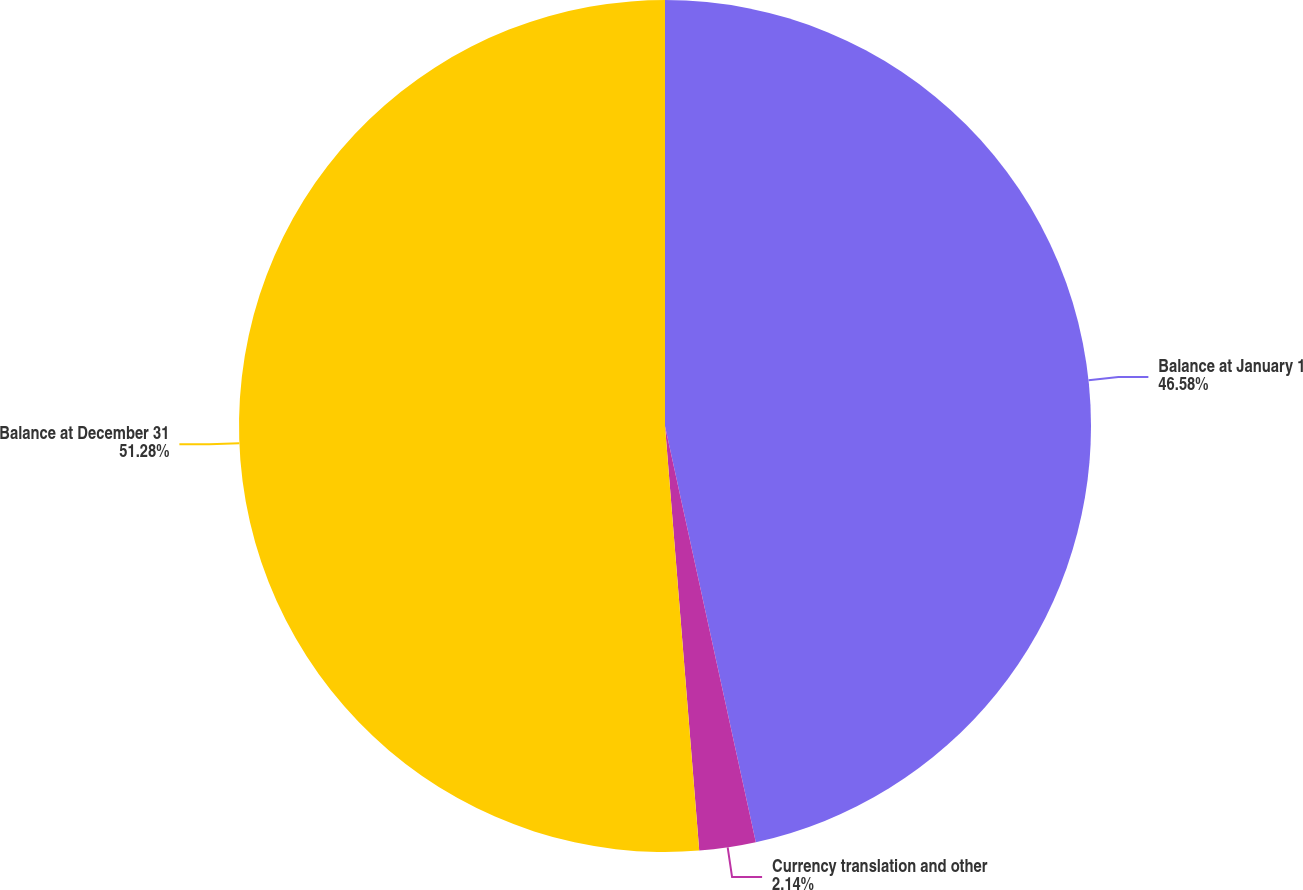Convert chart to OTSL. <chart><loc_0><loc_0><loc_500><loc_500><pie_chart><fcel>Balance at January 1<fcel>Currency translation and other<fcel>Balance at December 31<nl><fcel>46.58%<fcel>2.14%<fcel>51.28%<nl></chart> 